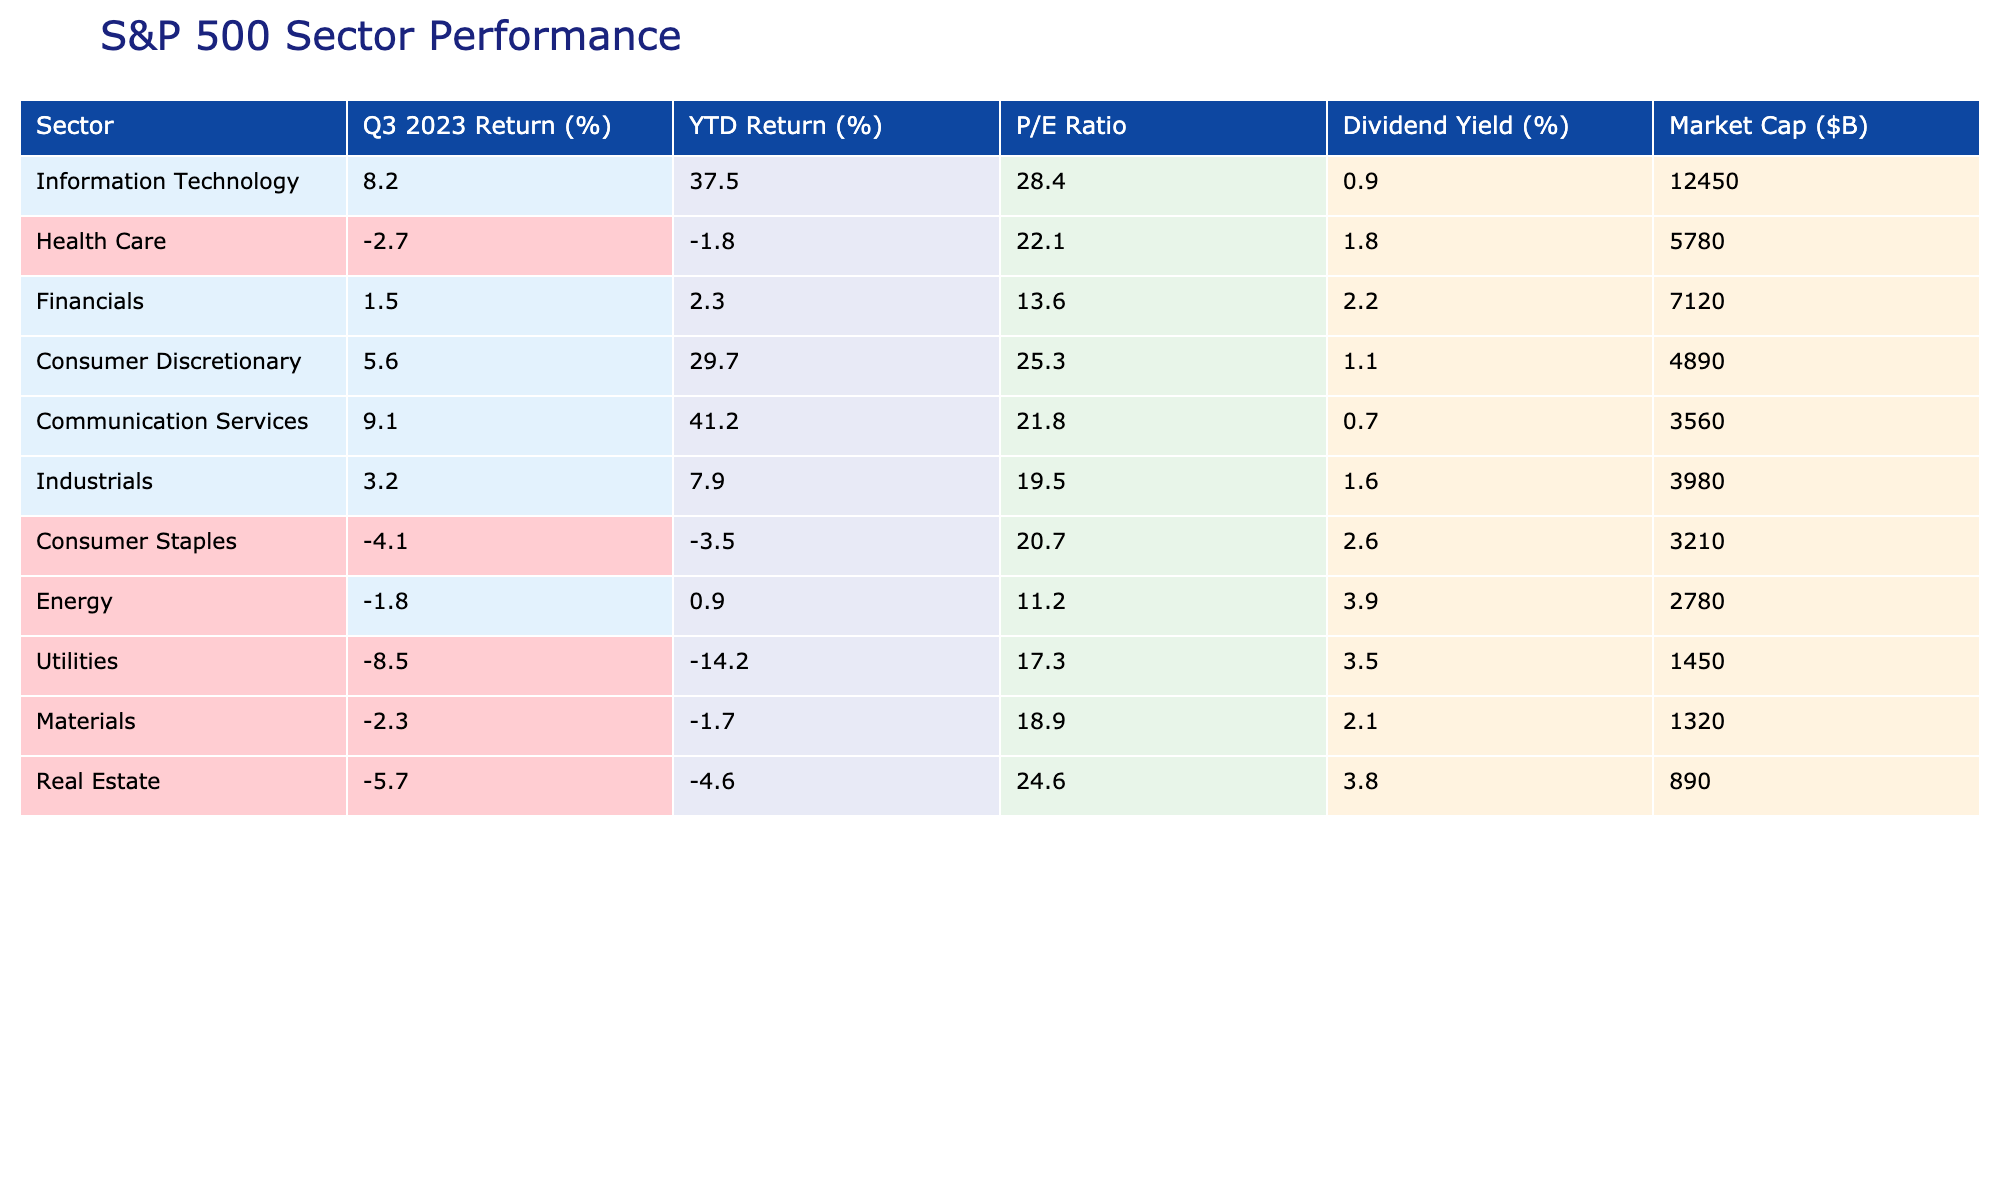What is the sector with the highest Q3 2023 return? By examining the "Q3 2023 Return (%)" column, the highest value is 9.1%, which corresponds to the "Communication Services" sector.
Answer: Communication Services Which sector has a Year-to-Date return below zero? Looking at the "YTD Return (%)" column, both "Health Care" (-1.8%) and "Utilities" (-14.2%) have negative returns, indicating that they are below zero.
Answer: Health Care, Utilities What is the average P/E Ratio of the sectors with positive Q3 returns? We first identify the sectors with positive Q3 returns, which are Information Technology, Communication Services, Consumer Discretionary, and Industrials. Their P/E Ratios are 28.4, 21.8, 25.3, and 19.5, respectively. Summing these gives 95.0, and there are 4 sectors, so the average P/E Ratio is 95.0/4 = 23.75.
Answer: 23.75 Which sector has the lowest Market Cap? By checking the "Market Cap ($B)" column, we find that "Utilities" has the lowest market cap at $1.45 billion.
Answer: Utilities Is the Consumer Staples sector's YTD return greater than its Q3 return? The YTD return for Consumer Staples is -3.5%, and the Q3 return is -4.1%. Since -3.5% is greater than -4.1%, the answer is yes.
Answer: Yes What is the difference in Market Cap between the Information Technology and Real Estate sectors? The Market Cap for Information Technology is $12,450 billion and for Real Estate, it is $890 billion. The difference is calculated as 12,450 - 890 = 11,560 billion.
Answer: 11,560 Which sector has the highest Dividend Yield? Looking at the "Dividend Yield (%)" column, "Energy" has the highest yield at 3.9%.
Answer: Energy What is the percentage of sectors with negative Q3 returns? The sectors with negative Q3 returns are Health Care, Consumer Staples, Energy, and Utilities, totaling 4 out of 11 sectors. Therefore, (4/11) * 100 = approximately 36.36%.
Answer: Approximately 36.36% Which sector has the highest YTD return, and what is that return? By reviewing the "YTD Return (%)" column, Communication Services has the highest YTD return at 41.2%.
Answer: 41.2% Is there a relationship between high P/E ratios and high returns in Q3? To examine this, we compare sectors with high P/E ratios against their Q3 returns. Sectors with P/E ratios above the average of about 22 (Information Technology, Communication Services, Consumer Discretionary) do show positive Q3 returns, suggesting there may be a correlation. However, this needs more extensive data for confirmation.
Answer: Yes, there is a correlation 